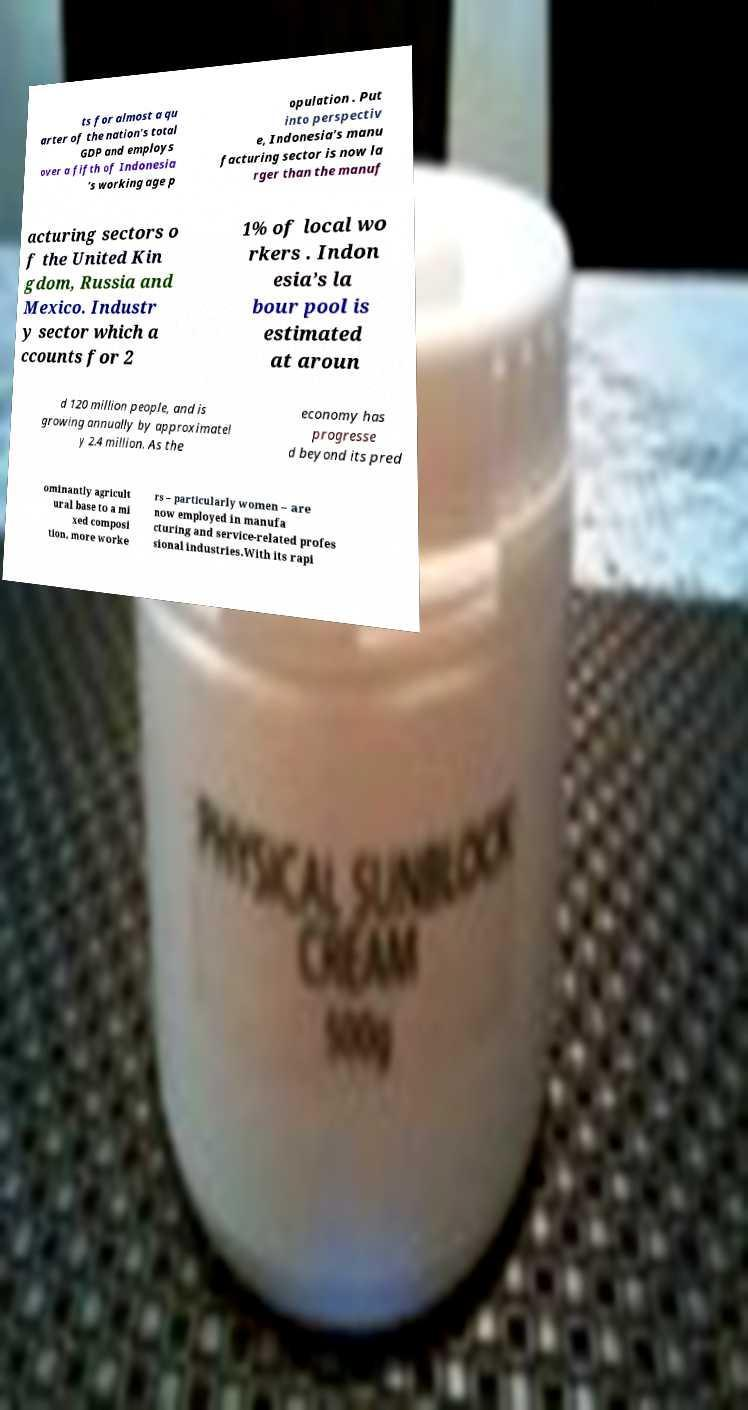What messages or text are displayed in this image? I need them in a readable, typed format. ts for almost a qu arter of the nation’s total GDP and employs over a fifth of Indonesia ’s working age p opulation . Put into perspectiv e, Indonesia’s manu facturing sector is now la rger than the manuf acturing sectors o f the United Kin gdom, Russia and Mexico. Industr y sector which a ccounts for 2 1% of local wo rkers . Indon esia’s la bour pool is estimated at aroun d 120 million people, and is growing annually by approximatel y 2.4 million. As the economy has progresse d beyond its pred ominantly agricult ural base to a mi xed composi tion, more worke rs – particularly women – are now employed in manufa cturing and service-related profes sional industries.With its rapi 